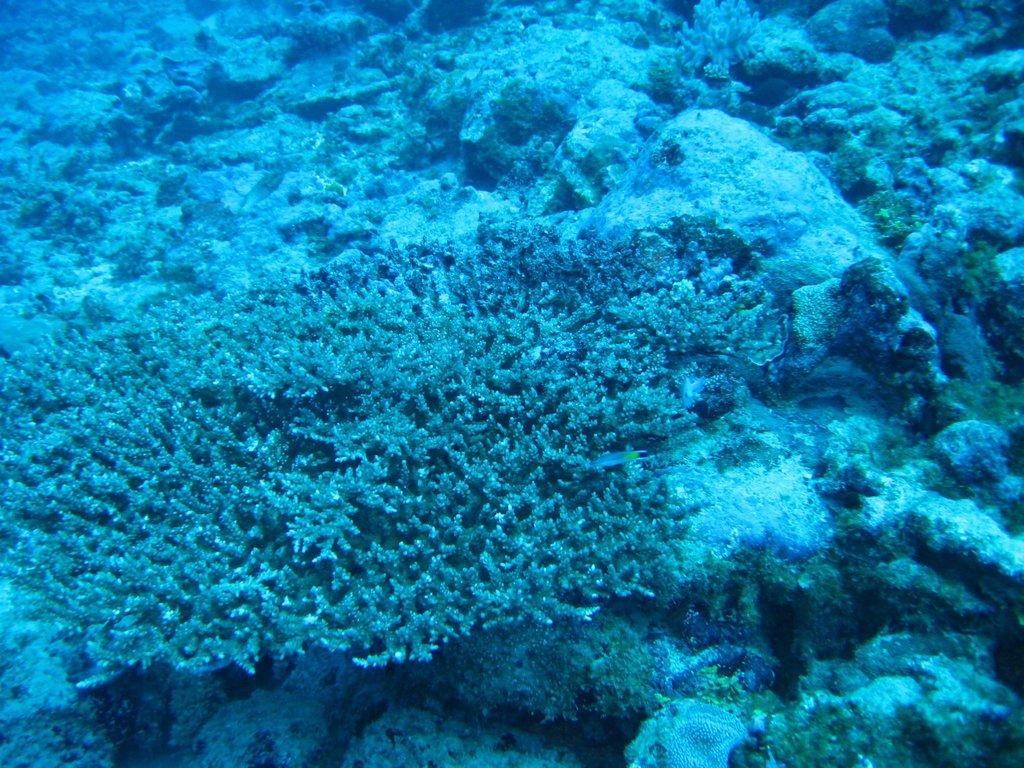What type of environment is shown in the image? The image depicts an underwater scene. What can be found in the underwater environment? There are plants and rocks in the underwater scene. How many parcels are being traded in the underwater scene? There are no parcels or trading activities depicted in the underwater scene; it only shows plants and rocks. 